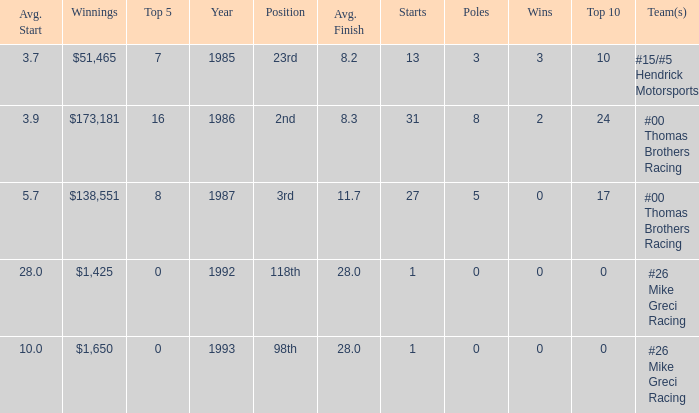How many years did he have an average finish of 11.7? 1.0. 